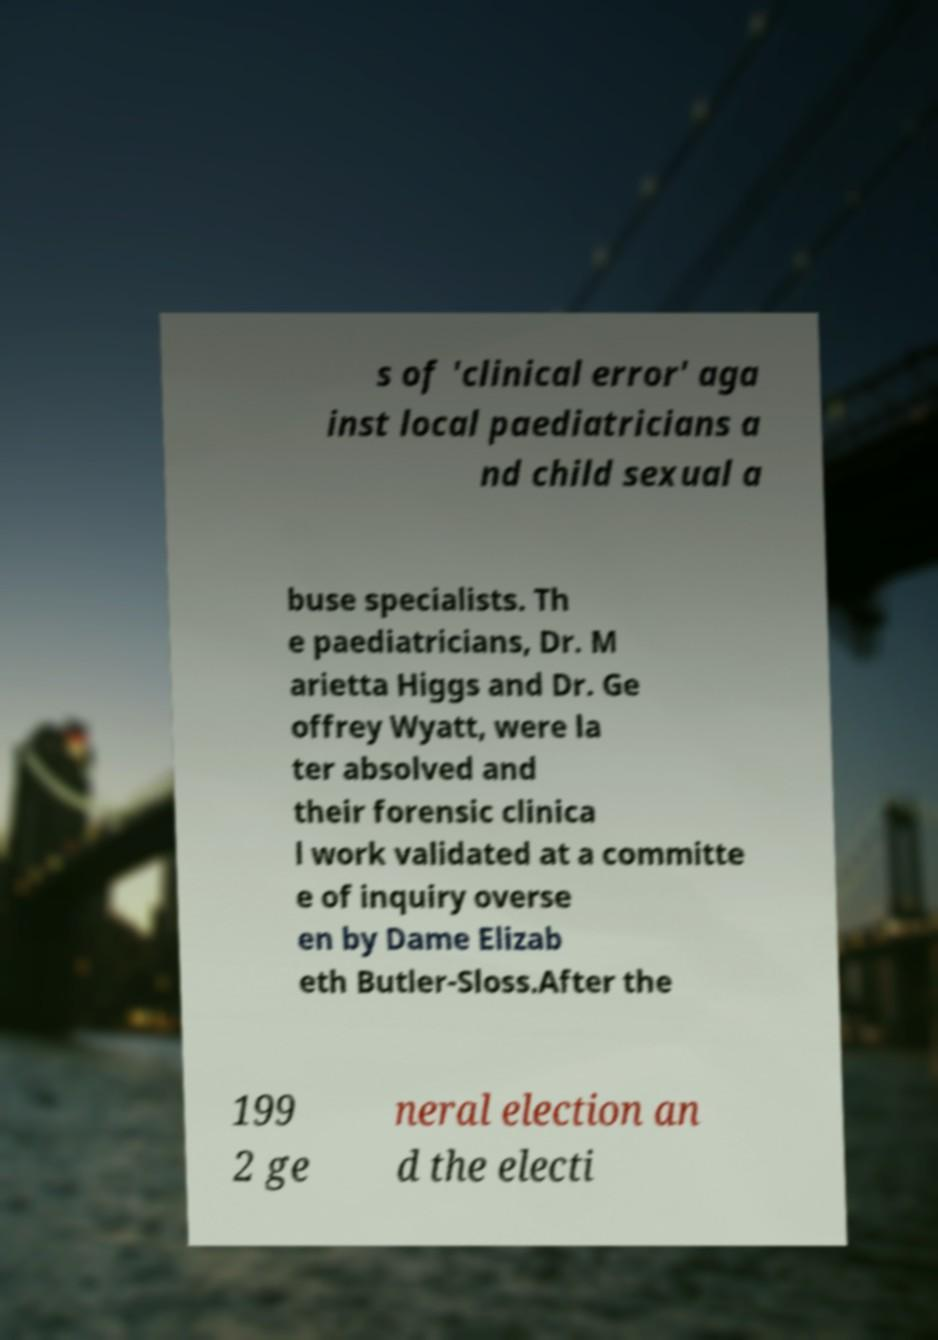There's text embedded in this image that I need extracted. Can you transcribe it verbatim? s of 'clinical error' aga inst local paediatricians a nd child sexual a buse specialists. Th e paediatricians, Dr. M arietta Higgs and Dr. Ge offrey Wyatt, were la ter absolved and their forensic clinica l work validated at a committe e of inquiry overse en by Dame Elizab eth Butler-Sloss.After the 199 2 ge neral election an d the electi 